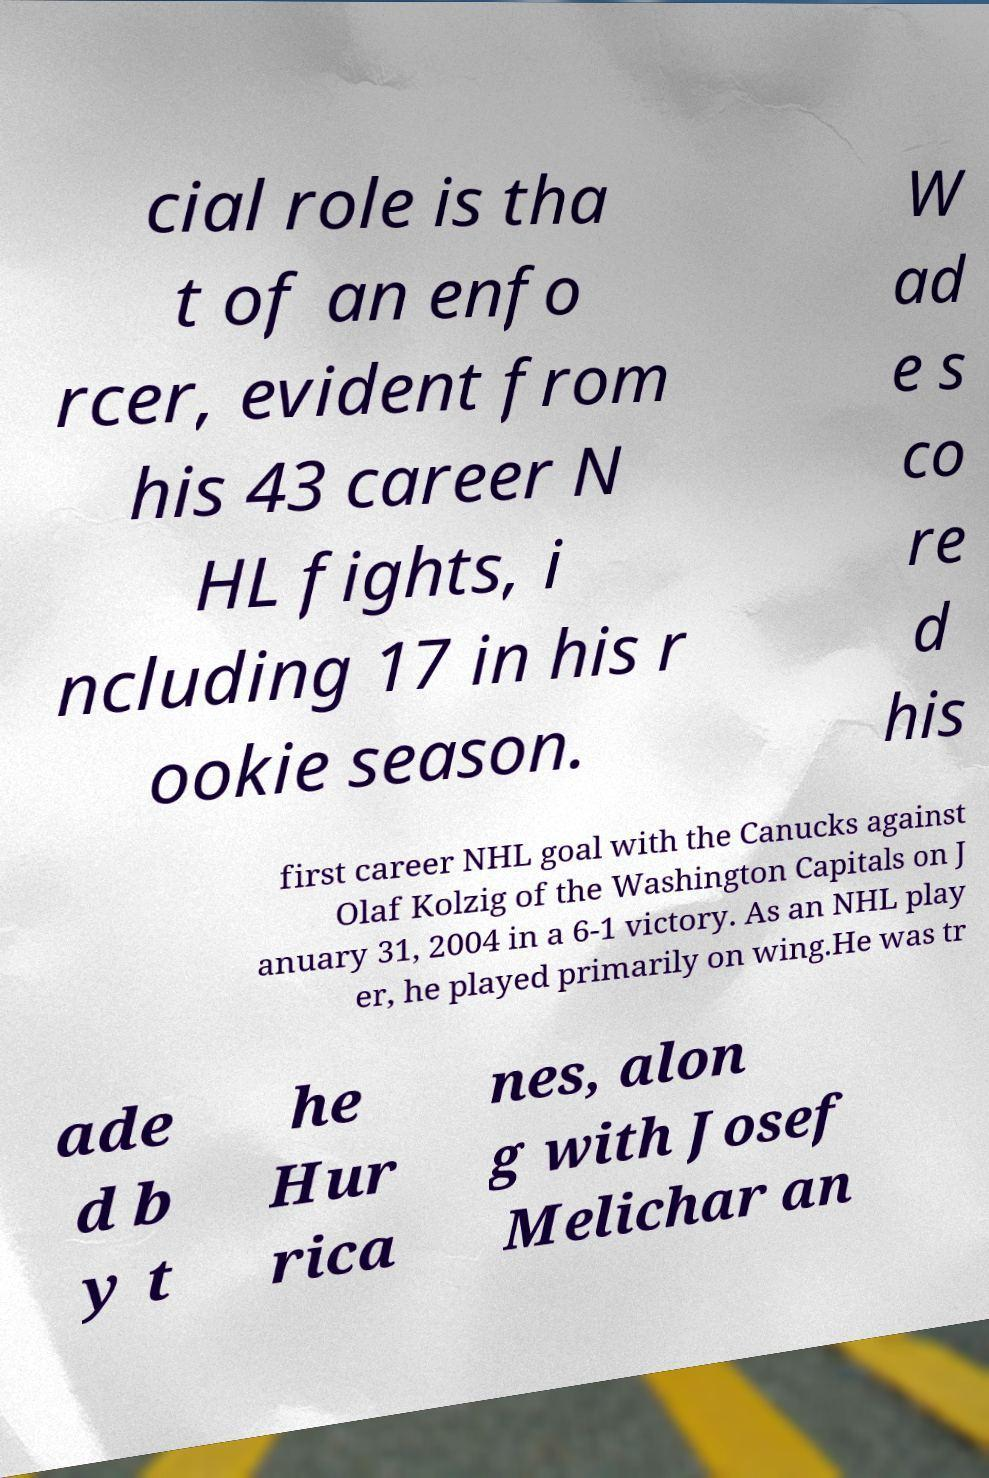What messages or text are displayed in this image? I need them in a readable, typed format. cial role is tha t of an enfo rcer, evident from his 43 career N HL fights, i ncluding 17 in his r ookie season. W ad e s co re d his first career NHL goal with the Canucks against Olaf Kolzig of the Washington Capitals on J anuary 31, 2004 in a 6-1 victory. As an NHL play er, he played primarily on wing.He was tr ade d b y t he Hur rica nes, alon g with Josef Melichar an 